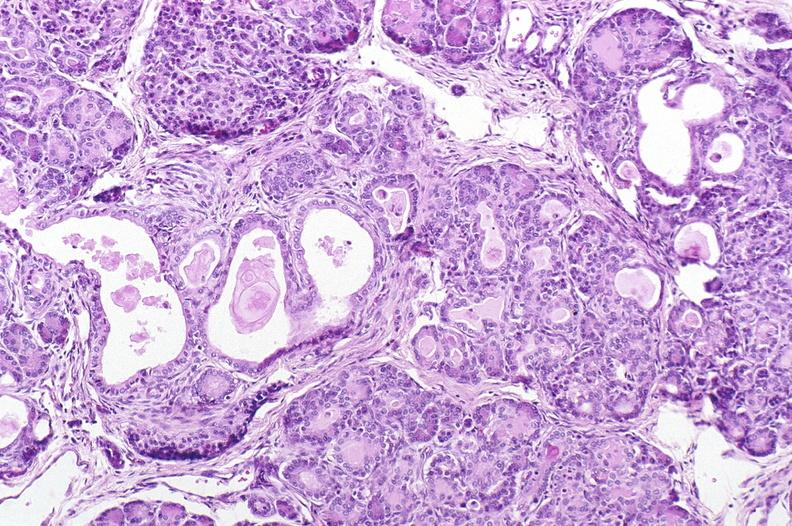where is this?
Answer the question using a single word or phrase. Pancreas 